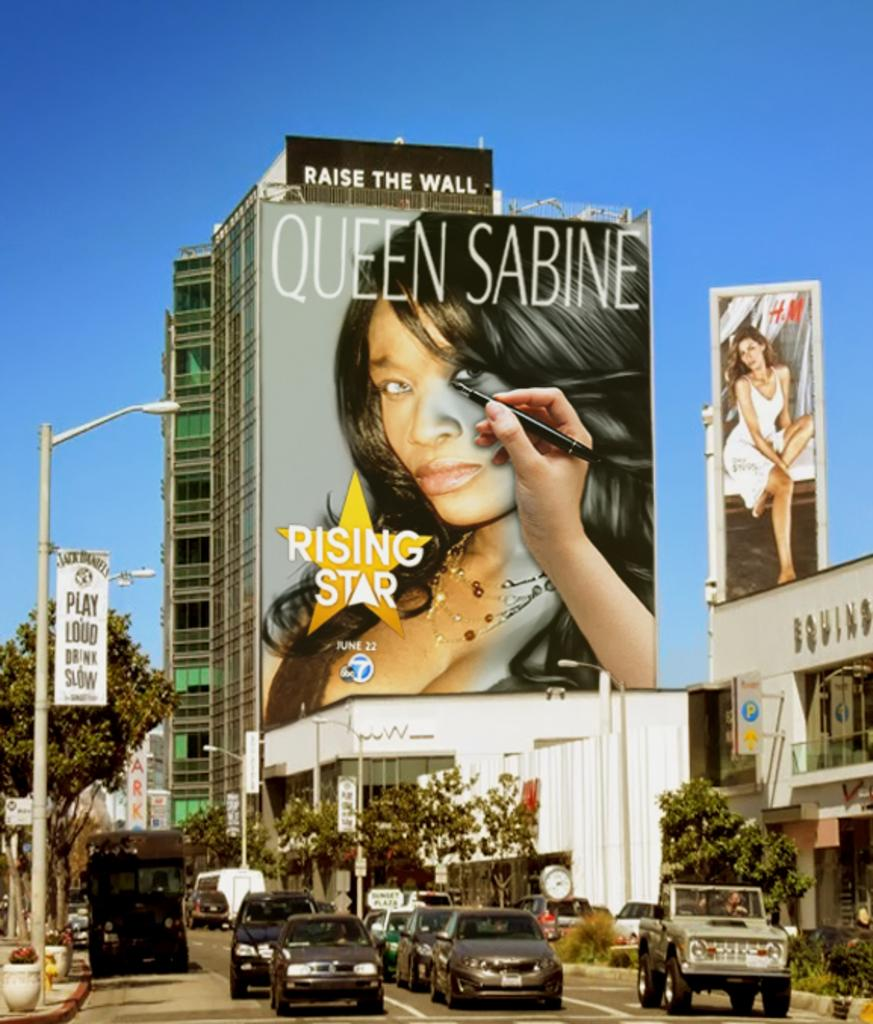<image>
Render a clear and concise summary of the photo. Big banner with Queen Sabine a rising star outside 